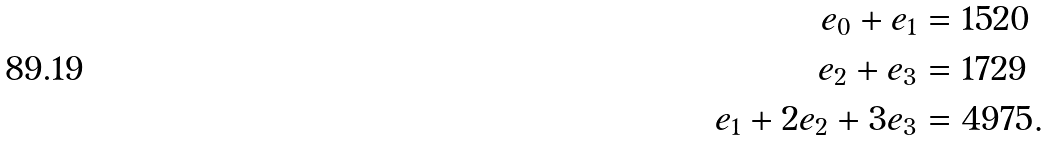Convert formula to latex. <formula><loc_0><loc_0><loc_500><loc_500>e _ { 0 } + e _ { 1 } & = 1 5 2 0 \\ e _ { 2 } + e _ { 3 } & = 1 7 2 9 \\ e _ { 1 } + 2 e _ { 2 } + 3 e _ { 3 } & = 4 9 7 5 .</formula> 